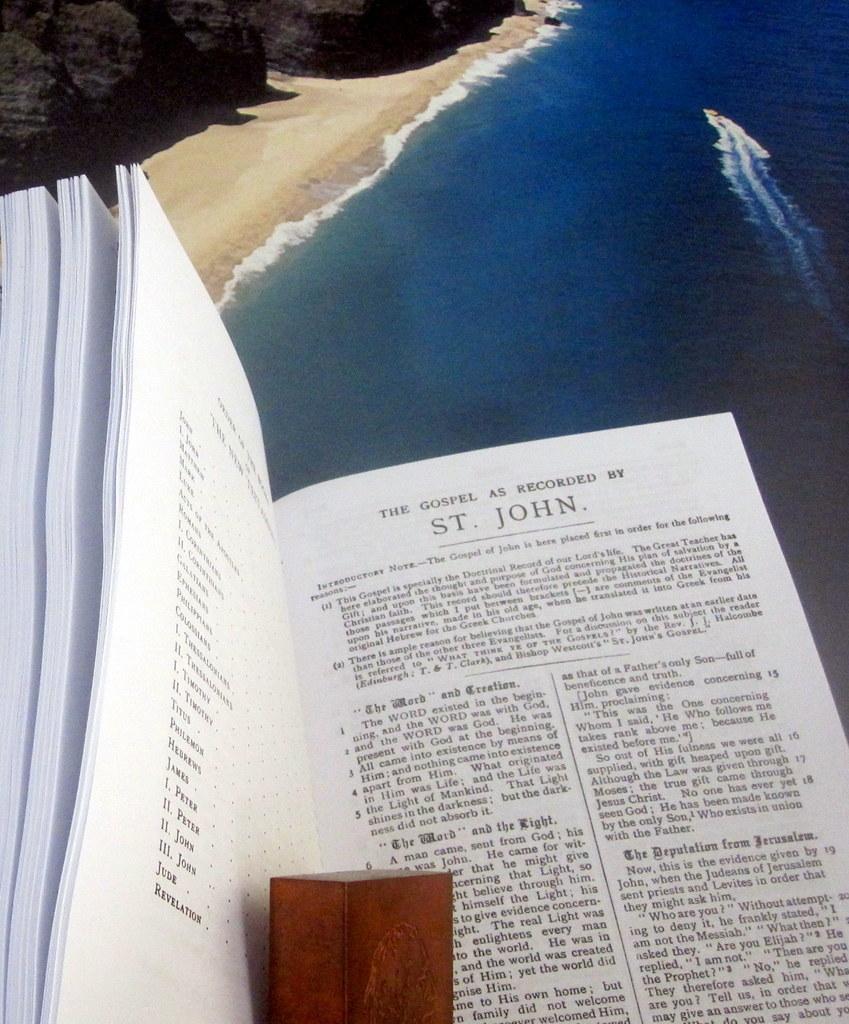What is written in bold text half way down the page on the right of the divider?
Keep it short and to the point. The deputation from jerusalem. 